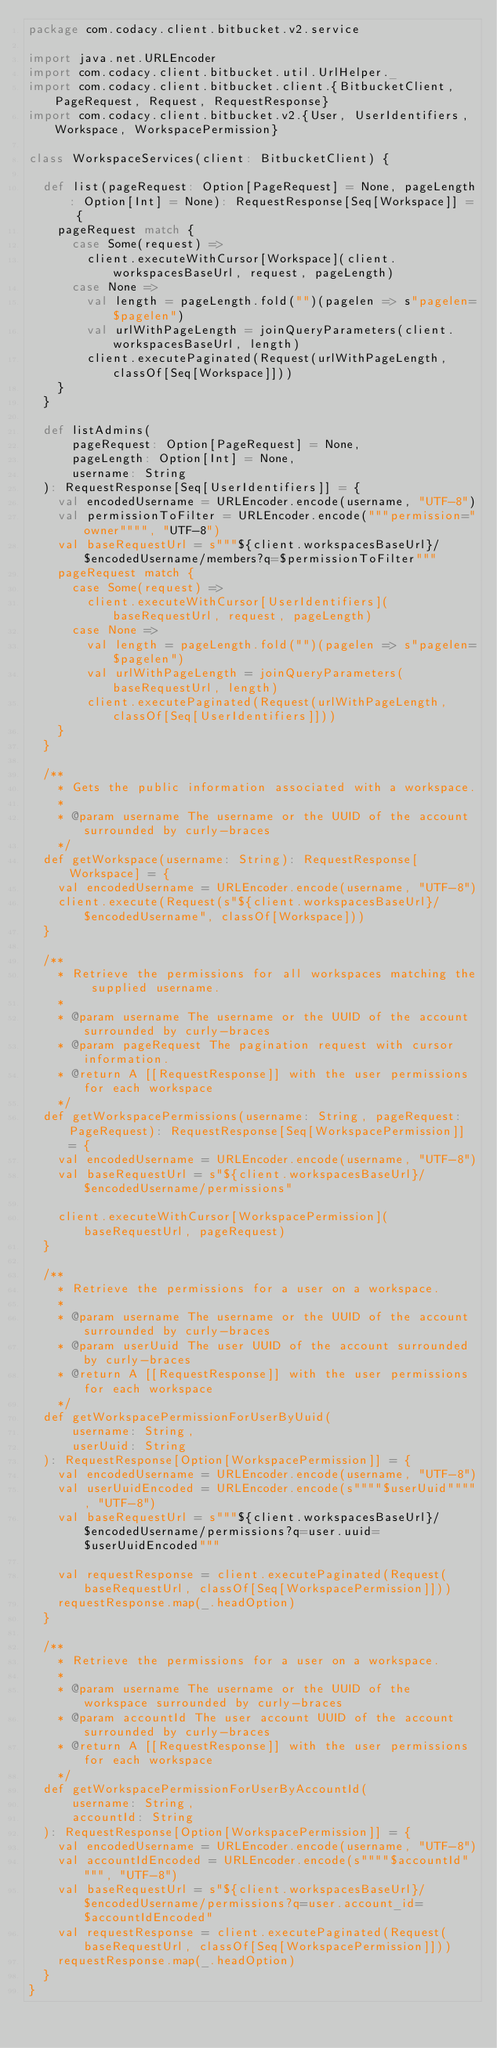<code> <loc_0><loc_0><loc_500><loc_500><_Scala_>package com.codacy.client.bitbucket.v2.service

import java.net.URLEncoder
import com.codacy.client.bitbucket.util.UrlHelper._
import com.codacy.client.bitbucket.client.{BitbucketClient, PageRequest, Request, RequestResponse}
import com.codacy.client.bitbucket.v2.{User, UserIdentifiers, Workspace, WorkspacePermission}

class WorkspaceServices(client: BitbucketClient) {

  def list(pageRequest: Option[PageRequest] = None, pageLength: Option[Int] = None): RequestResponse[Seq[Workspace]] = {
    pageRequest match {
      case Some(request) =>
        client.executeWithCursor[Workspace](client.workspacesBaseUrl, request, pageLength)
      case None =>
        val length = pageLength.fold("")(pagelen => s"pagelen=$pagelen")
        val urlWithPageLength = joinQueryParameters(client.workspacesBaseUrl, length)
        client.executePaginated(Request(urlWithPageLength, classOf[Seq[Workspace]]))
    }
  }

  def listAdmins(
      pageRequest: Option[PageRequest] = None,
      pageLength: Option[Int] = None,
      username: String
  ): RequestResponse[Seq[UserIdentifiers]] = {
    val encodedUsername = URLEncoder.encode(username, "UTF-8")
    val permissionToFilter = URLEncoder.encode("""permission="owner"""", "UTF-8")
    val baseRequestUrl = s"""${client.workspacesBaseUrl}/$encodedUsername/members?q=$permissionToFilter"""
    pageRequest match {
      case Some(request) =>
        client.executeWithCursor[UserIdentifiers](baseRequestUrl, request, pageLength)
      case None =>
        val length = pageLength.fold("")(pagelen => s"pagelen=$pagelen")
        val urlWithPageLength = joinQueryParameters(baseRequestUrl, length)
        client.executePaginated(Request(urlWithPageLength, classOf[Seq[UserIdentifiers]]))
    }
  }

  /**
    * Gets the public information associated with a workspace.
    *
    * @param username The username or the UUID of the account surrounded by curly-braces
    */
  def getWorkspace(username: String): RequestResponse[Workspace] = {
    val encodedUsername = URLEncoder.encode(username, "UTF-8")
    client.execute(Request(s"${client.workspacesBaseUrl}/$encodedUsername", classOf[Workspace]))
  }

  /**
    * Retrieve the permissions for all workspaces matching the supplied username.
    *
    * @param username The username or the UUID of the account surrounded by curly-braces
    * @param pageRequest The pagination request with cursor information.
    * @return A [[RequestResponse]] with the user permissions for each workspace
    */
  def getWorkspacePermissions(username: String, pageRequest: PageRequest): RequestResponse[Seq[WorkspacePermission]] = {
    val encodedUsername = URLEncoder.encode(username, "UTF-8")
    val baseRequestUrl = s"${client.workspacesBaseUrl}/$encodedUsername/permissions"

    client.executeWithCursor[WorkspacePermission](baseRequestUrl, pageRequest)
  }

  /**
    * Retrieve the permissions for a user on a workspace.
    *
    * @param username The username or the UUID of the account surrounded by curly-braces
    * @param userUuid The user UUID of the account surrounded by curly-braces
    * @return A [[RequestResponse]] with the user permissions for each workspace
    */
  def getWorkspacePermissionForUserByUuid(
      username: String,
      userUuid: String
  ): RequestResponse[Option[WorkspacePermission]] = {
    val encodedUsername = URLEncoder.encode(username, "UTF-8")
    val userUuidEncoded = URLEncoder.encode(s""""$userUuid"""", "UTF-8")
    val baseRequestUrl = s"""${client.workspacesBaseUrl}/$encodedUsername/permissions?q=user.uuid=$userUuidEncoded"""

    val requestResponse = client.executePaginated(Request(baseRequestUrl, classOf[Seq[WorkspacePermission]]))
    requestResponse.map(_.headOption)
  }

  /**
    * Retrieve the permissions for a user on a workspace.
    *
    * @param username The username or the UUID of the workspace surrounded by curly-braces
    * @param accountId The user account UUID of the account surrounded by curly-braces
    * @return A [[RequestResponse]] with the user permissions for each workspace
    */
  def getWorkspacePermissionForUserByAccountId(
      username: String,
      accountId: String
  ): RequestResponse[Option[WorkspacePermission]] = {
    val encodedUsername = URLEncoder.encode(username, "UTF-8")
    val accountIdEncoded = URLEncoder.encode(s""""$accountId"""", "UTF-8")
    val baseRequestUrl = s"${client.workspacesBaseUrl}/$encodedUsername/permissions?q=user.account_id=$accountIdEncoded"
    val requestResponse = client.executePaginated(Request(baseRequestUrl, classOf[Seq[WorkspacePermission]]))
    requestResponse.map(_.headOption)
  }
}
</code> 